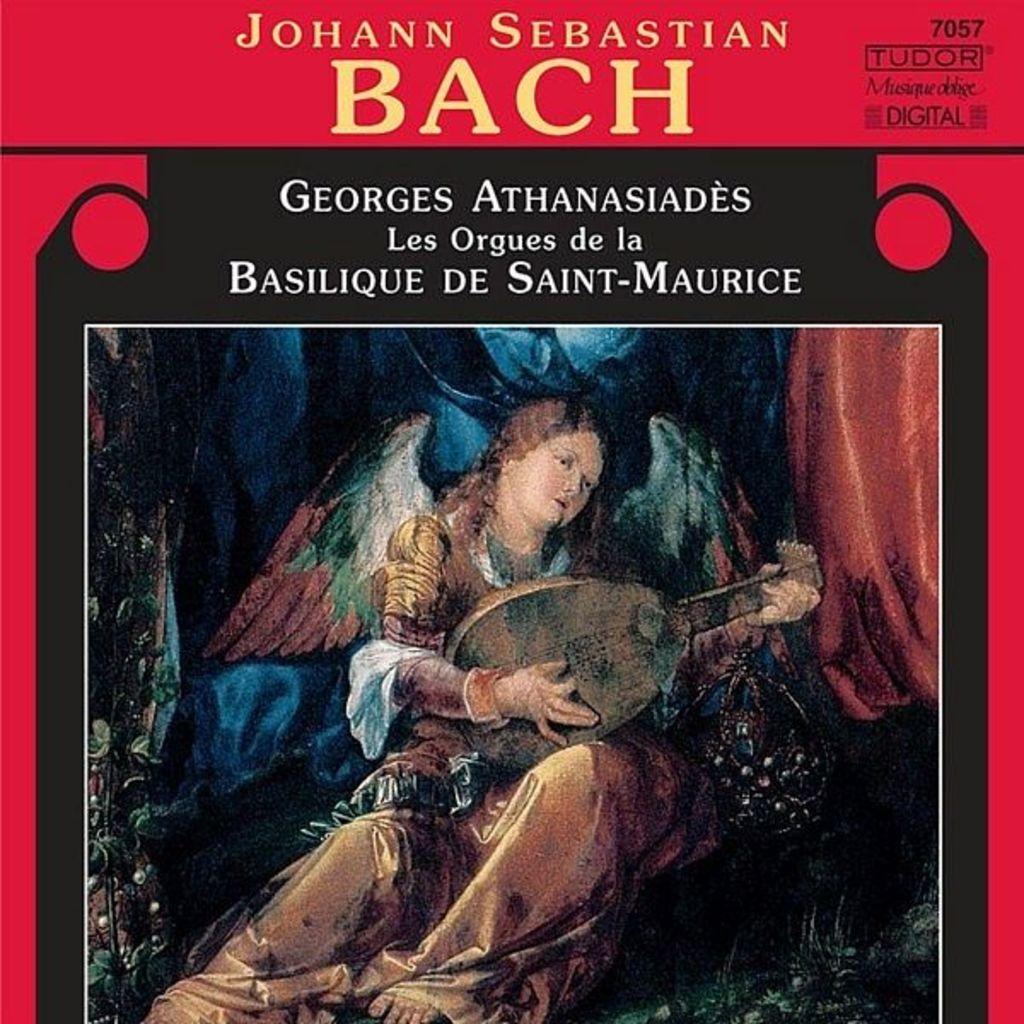What is this music called?
Offer a terse response. Bach. 